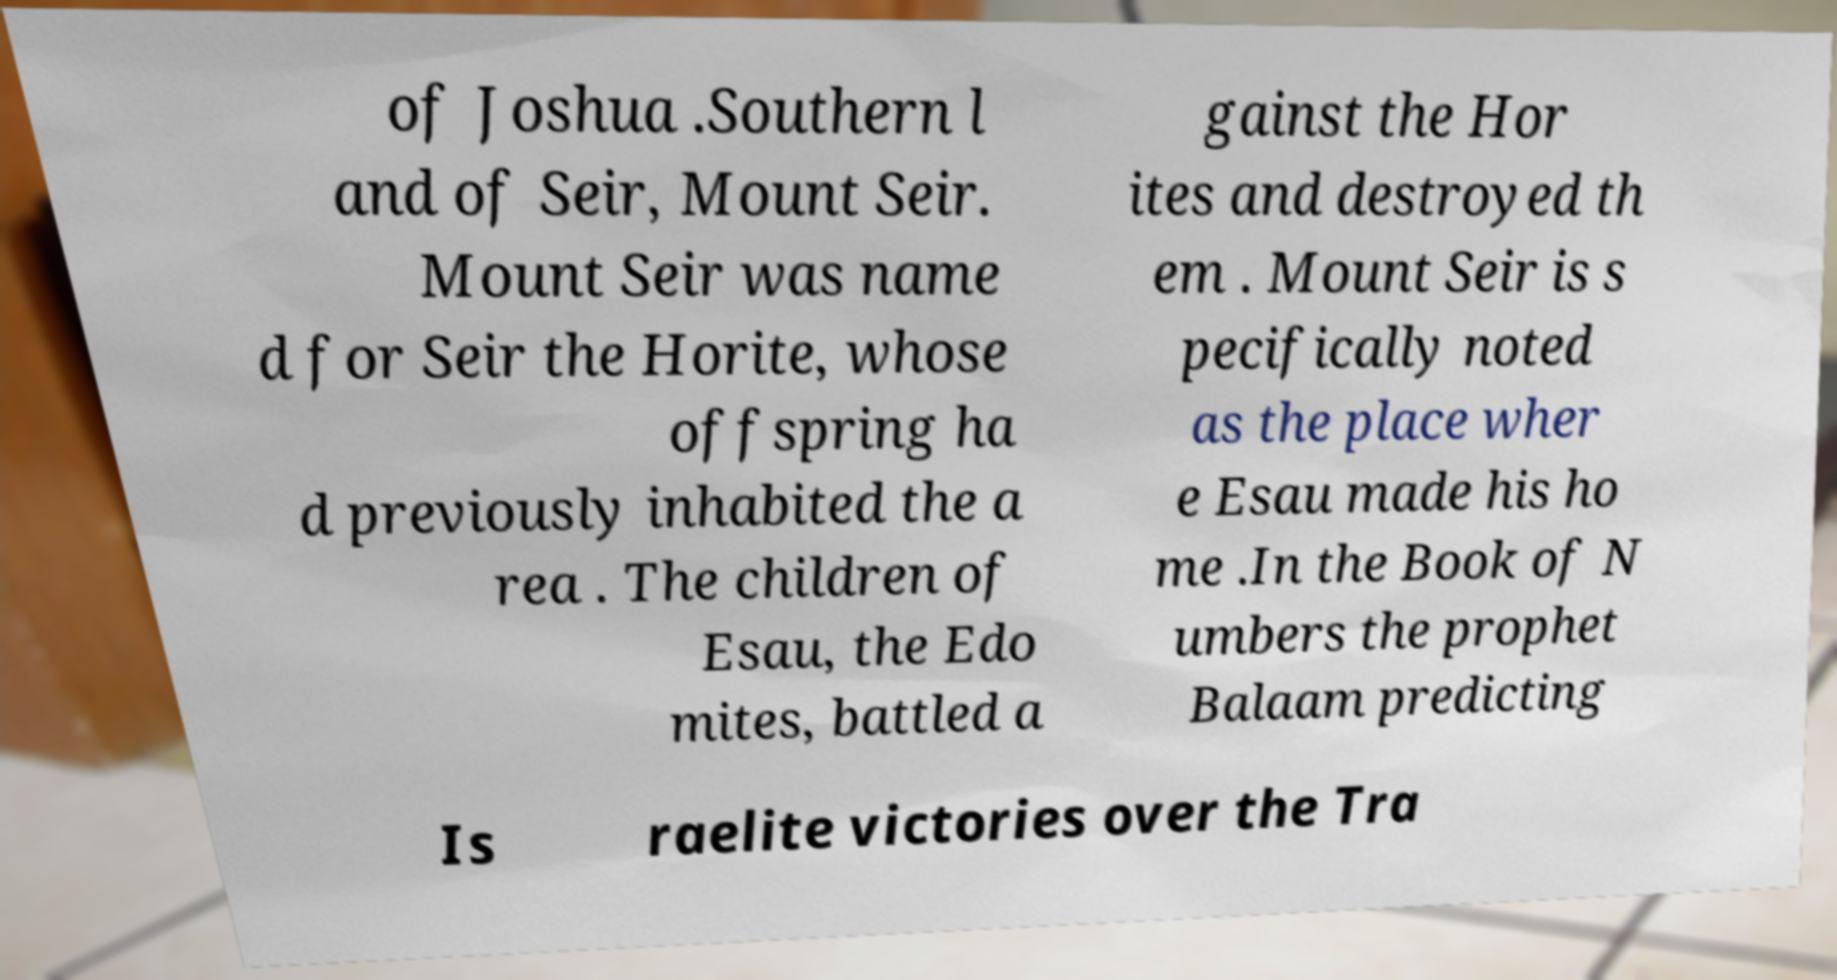I need the written content from this picture converted into text. Can you do that? of Joshua .Southern l and of Seir, Mount Seir. Mount Seir was name d for Seir the Horite, whose offspring ha d previously inhabited the a rea . The children of Esau, the Edo mites, battled a gainst the Hor ites and destroyed th em . Mount Seir is s pecifically noted as the place wher e Esau made his ho me .In the Book of N umbers the prophet Balaam predicting Is raelite victories over the Tra 